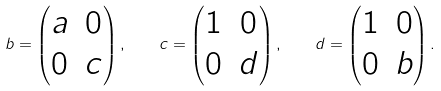<formula> <loc_0><loc_0><loc_500><loc_500>b = \begin{pmatrix} a & 0 \\ 0 & c \end{pmatrix} , \quad c = \begin{pmatrix} 1 & 0 \\ 0 & d \end{pmatrix} , \quad d = \begin{pmatrix} 1 & 0 \\ 0 & b \end{pmatrix} .</formula> 